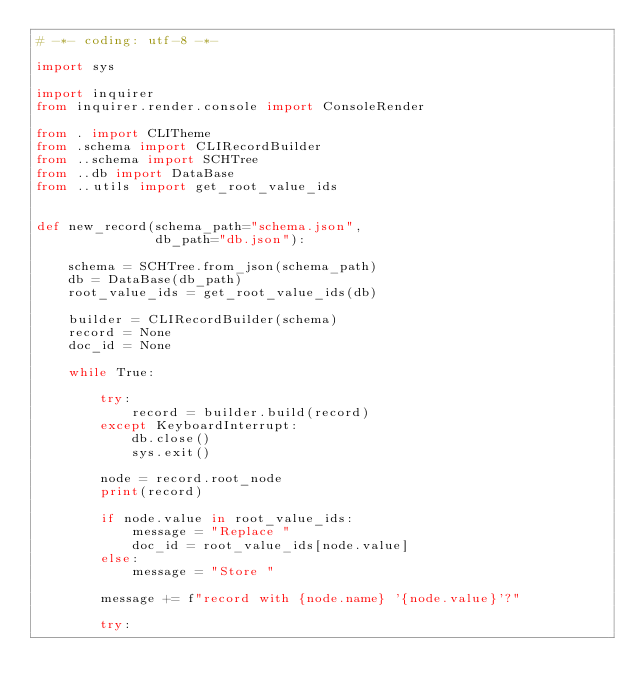Convert code to text. <code><loc_0><loc_0><loc_500><loc_500><_Python_># -*- coding: utf-8 -*-

import sys

import inquirer
from inquirer.render.console import ConsoleRender

from . import CLITheme
from .schema import CLIRecordBuilder
from ..schema import SCHTree
from ..db import DataBase
from ..utils import get_root_value_ids


def new_record(schema_path="schema.json",
               db_path="db.json"):
    
    schema = SCHTree.from_json(schema_path)
    db = DataBase(db_path)
    root_value_ids = get_root_value_ids(db)
    
    builder = CLIRecordBuilder(schema)
    record = None
    doc_id = None
    
    while True:
        
        try:
            record = builder.build(record)
        except KeyboardInterrupt:
            db.close()
            sys.exit()
        
        node = record.root_node
        print(record)
        
        if node.value in root_value_ids:
            message = "Replace "
            doc_id = root_value_ids[node.value]
        else:
            message = "Store "
        
        message += f"record with {node.name} '{node.value}'?"
        
        try:</code> 